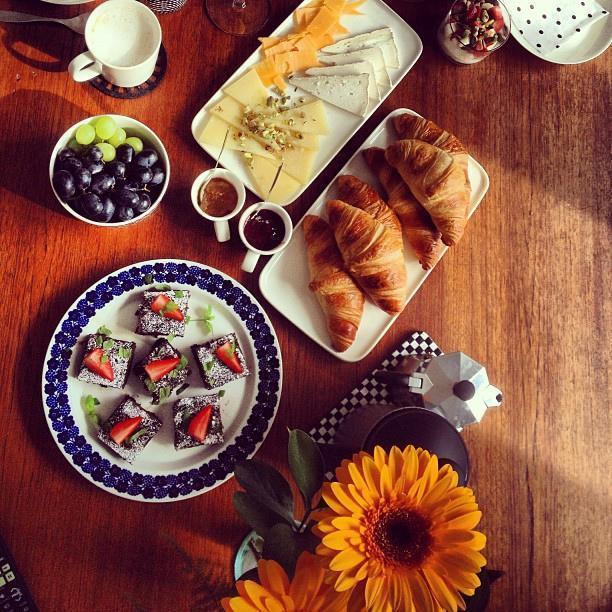Is "The potted plant is at the edge of the dining table." an appropriate description for the image?
Answer yes or no. No. 